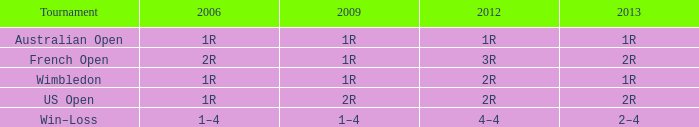What is the contest when the 2013 is 1r? Australian Open, Wimbledon. 